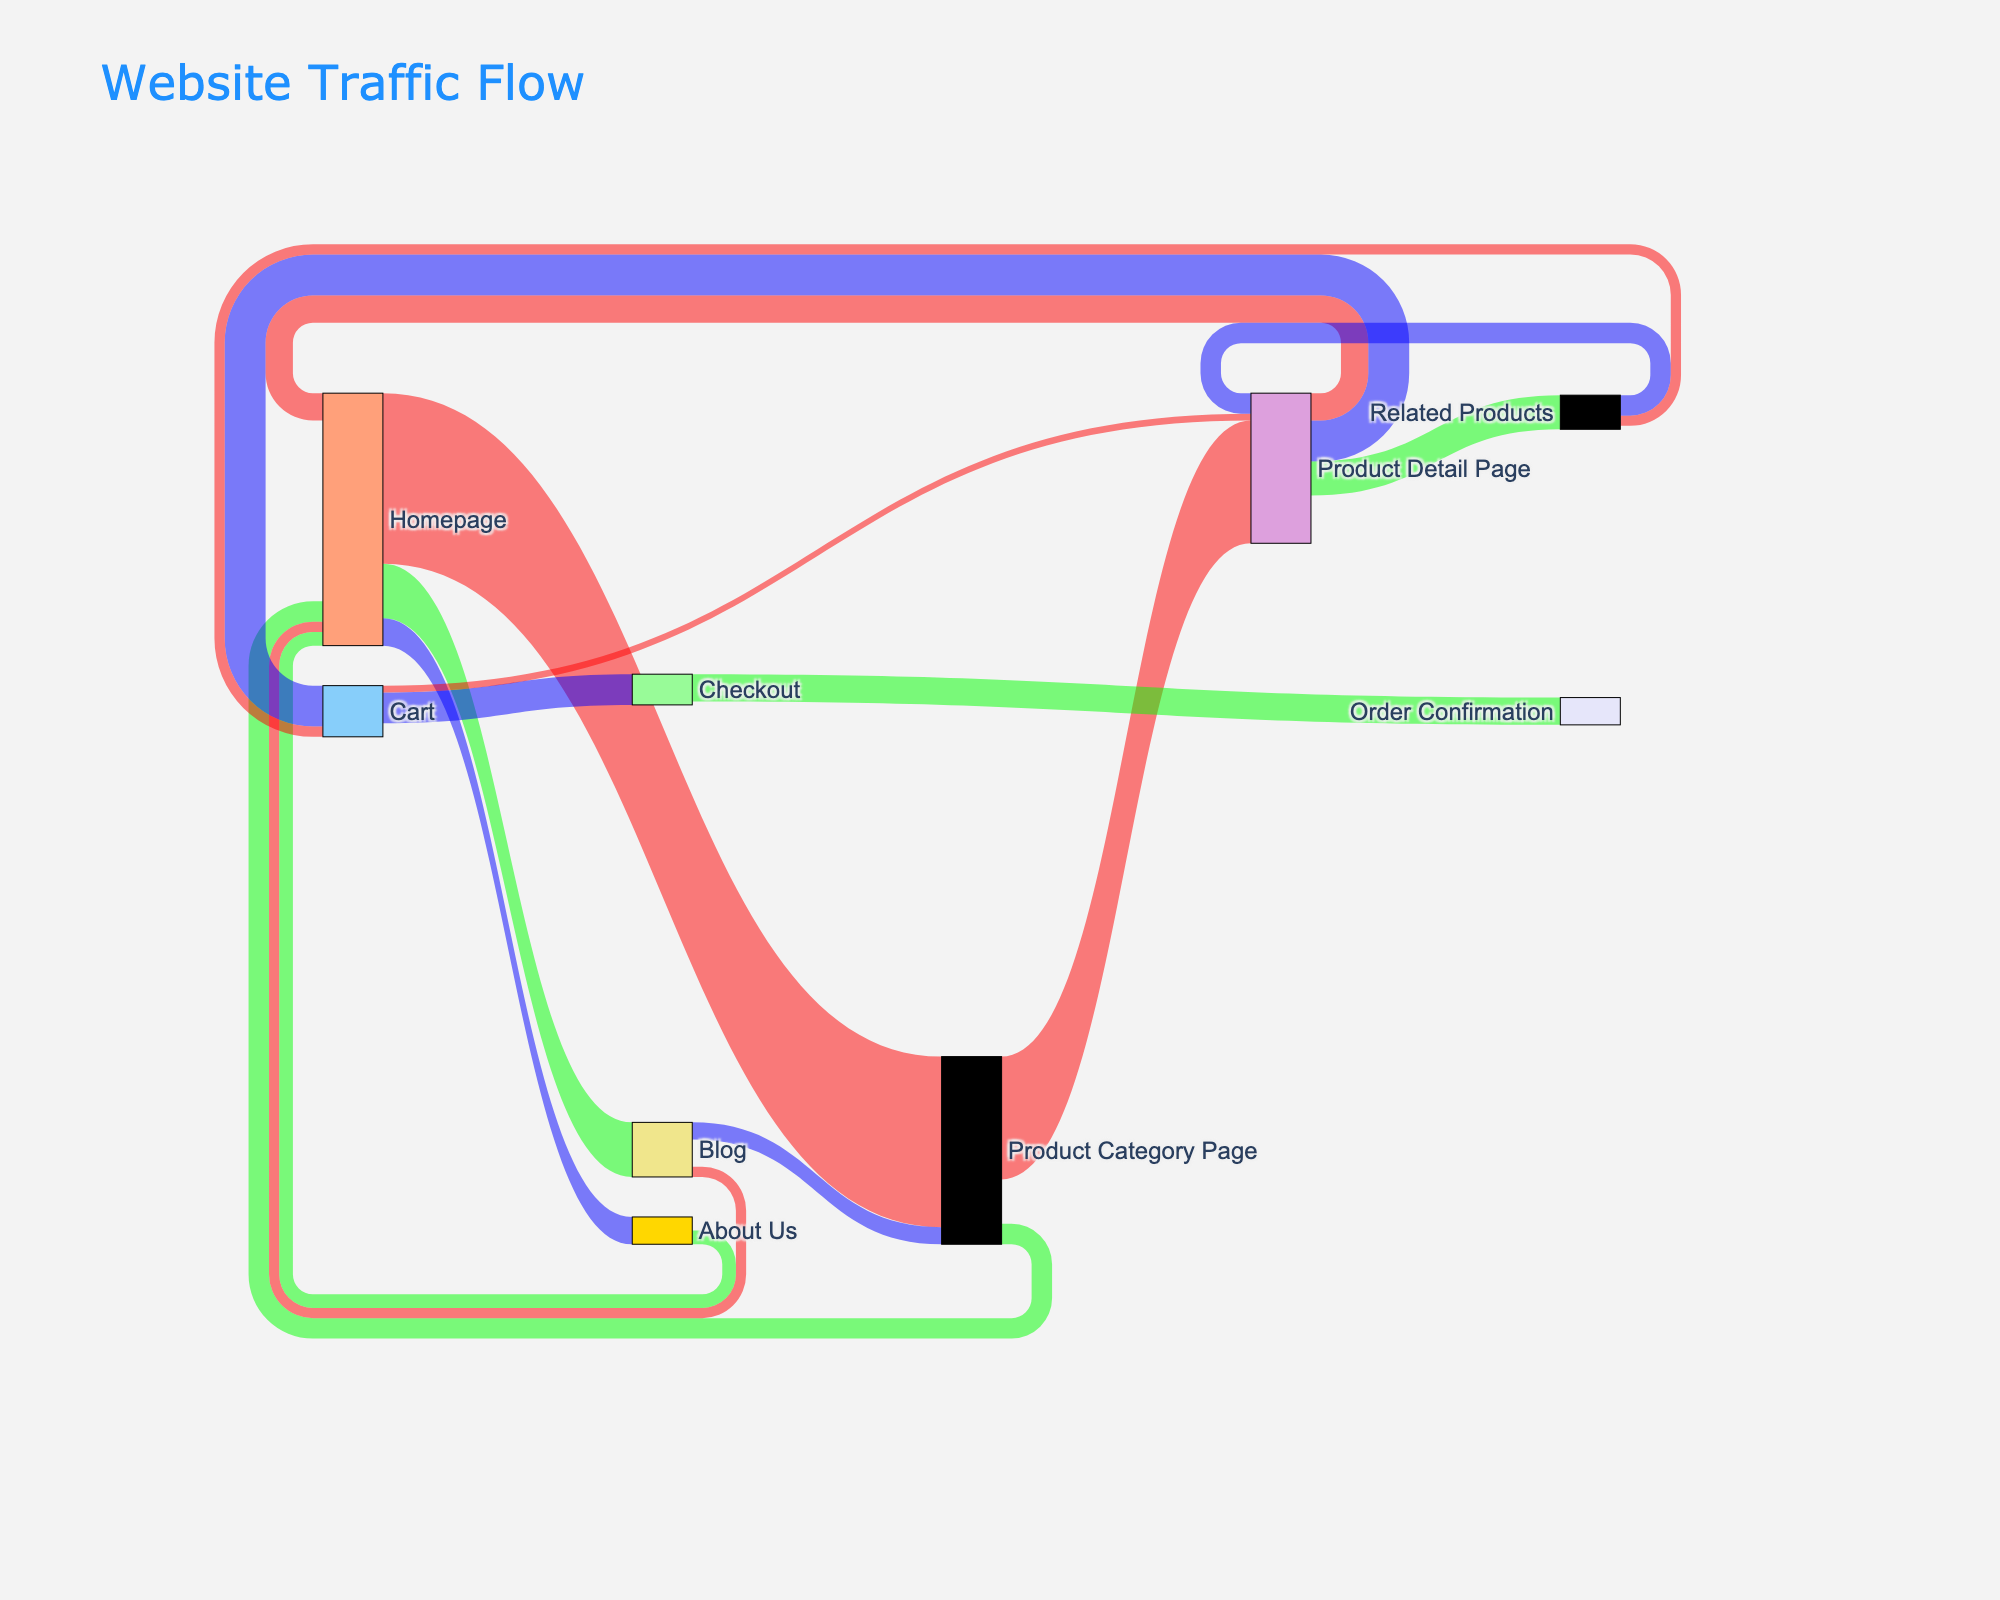What is the title of the Sankey diagram? The title of the Sankey diagram is usually placed at the top of the figure, indicating the main subject being represented. In this case, it is "Website Traffic Flow".
Answer: Website Traffic Flow How many nodes are there in the Sankey diagram? Count the distinct labels for the nodes; the nodes are listed in the "label" attribute of the node dictionary.
Answer: 10 Which page has the highest traffic flow from the Homepage? Look for the link with the highest value originating from the Homepage by comparing the values. The highest value among links from the Homepage is 2500, which points to the Product Category Page.
Answer: Product Category Page What is the total number of visitors that transition from the Product Category Page? Sum up the values of all links originating from the Product Category Page. The links are:
- to Product Detail Page: 1800
- to Homepage: 300 
So, 1800 + 300 = 2100.
Answer: 2100 How many visitors went from the Product Detail Page to the Cart compared to the Homepage? Compare the values of the links from Product Detail Page. 
- Product Detail Page to Cart = 600 
- Product Detail Page to Homepage = 400 
Since 600 > 400, more visitors went to the Cart.
Answer: More went to Cart Which page successfully drives the most traffic to the Homepage? Look for the highest value among links where the `target` is the Homepage. These are:
- From Product Category Page: 300
- From Blog: 150
- From About Us: 200
- From Product Detail Page: 400
The highest value is 400 from Product Detail Page.
Answer: Product Detail Page What percentage of visitors reach the Checkout page after adding items to the Cart? First, identify the flow values:
- Cart to Checkout = 450
- Cart total outflow = 450 (to Checkout) + 100 (back to Product Detail Page) = 550
Now, calculate the percentage: (450 / 550) * 100 ≈ 81.8%
Answer: 81.8% What is the combined traffic from the Product Detail Page to other pages? Sum the values of all outgoing links from the Product Detail Page:
- To Cart: 600
- To Homepage: 400
- To Related Products: 500
The total combined traffic is 600 + 400 + 500 = 1500.
Answer: 1500 How does the traffic from the Blog compare to traffic from the About Us page, both returning to the Homepage? Compare the values of the links returning to the Homepage:
- From Blog: 150
- From About Us: 200
Since 200 > 150, the About Us page has more returning traffic to the Homepage.
Answer: About Us > Blog Which transition has the smallest traffic flow? Identify the link with the smallest value in the Sankey diagram data:
- Cart to Product Detail Page has a value of 100, which is the smallest in the dataset.
Answer: Cart to Product Detail Page 